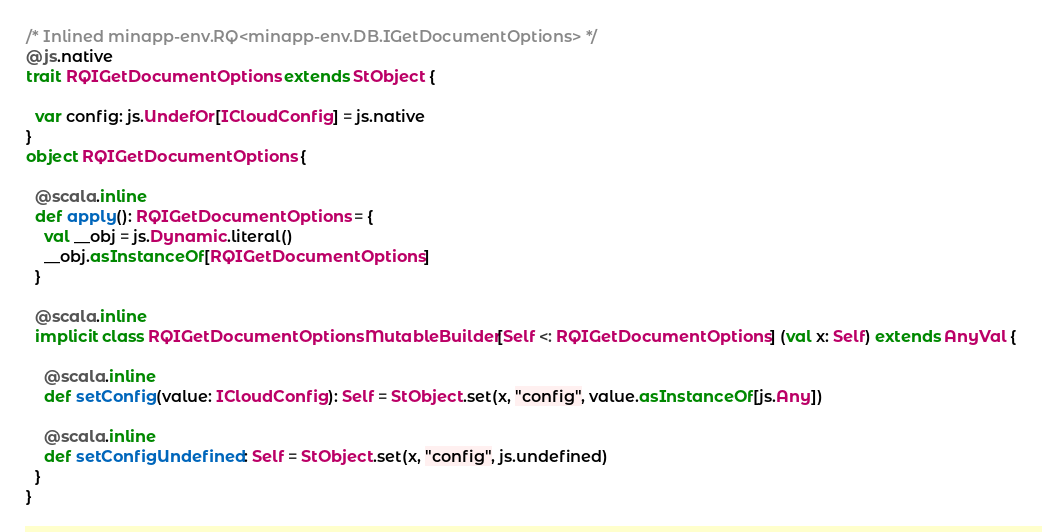<code> <loc_0><loc_0><loc_500><loc_500><_Scala_>/* Inlined minapp-env.RQ<minapp-env.DB.IGetDocumentOptions> */
@js.native
trait RQIGetDocumentOptions extends StObject {
  
  var config: js.UndefOr[ICloudConfig] = js.native
}
object RQIGetDocumentOptions {
  
  @scala.inline
  def apply(): RQIGetDocumentOptions = {
    val __obj = js.Dynamic.literal()
    __obj.asInstanceOf[RQIGetDocumentOptions]
  }
  
  @scala.inline
  implicit class RQIGetDocumentOptionsMutableBuilder[Self <: RQIGetDocumentOptions] (val x: Self) extends AnyVal {
    
    @scala.inline
    def setConfig(value: ICloudConfig): Self = StObject.set(x, "config", value.asInstanceOf[js.Any])
    
    @scala.inline
    def setConfigUndefined: Self = StObject.set(x, "config", js.undefined)
  }
}
</code> 